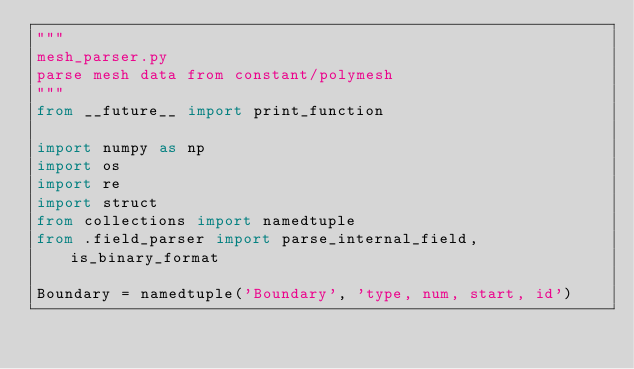Convert code to text. <code><loc_0><loc_0><loc_500><loc_500><_Python_>"""
mesh_parser.py
parse mesh data from constant/polymesh
"""
from __future__ import print_function

import numpy as np
import os
import re
import struct
from collections import namedtuple
from .field_parser import parse_internal_field, is_binary_format

Boundary = namedtuple('Boundary', 'type, num, start, id')
</code> 